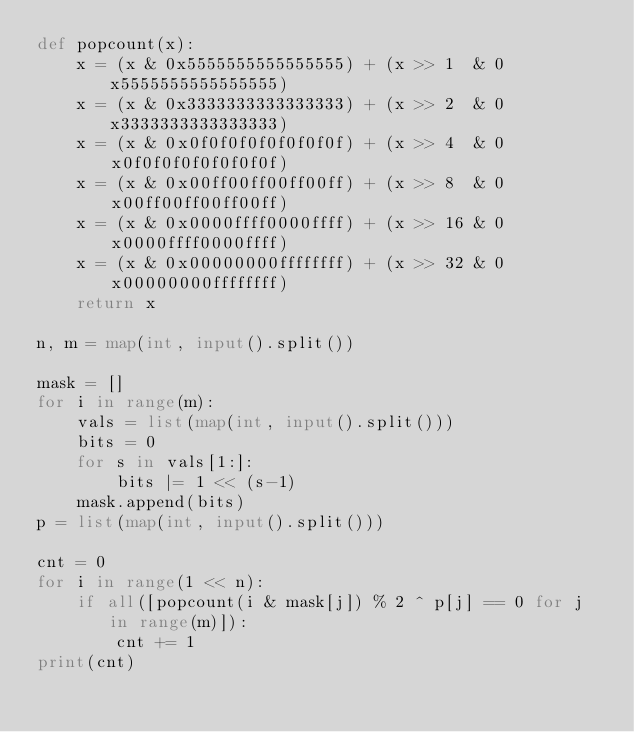Convert code to text. <code><loc_0><loc_0><loc_500><loc_500><_Python_>def popcount(x):
    x = (x & 0x5555555555555555) + (x >> 1  & 0x5555555555555555)
    x = (x & 0x3333333333333333) + (x >> 2  & 0x3333333333333333)
    x = (x & 0x0f0f0f0f0f0f0f0f) + (x >> 4  & 0x0f0f0f0f0f0f0f0f)
    x = (x & 0x00ff00ff00ff00ff) + (x >> 8  & 0x00ff00ff00ff00ff)
    x = (x & 0x0000ffff0000ffff) + (x >> 16 & 0x0000ffff0000ffff)
    x = (x & 0x00000000ffffffff) + (x >> 32 & 0x00000000ffffffff)
    return x

n, m = map(int, input().split())

mask = []
for i in range(m):
    vals = list(map(int, input().split()))
    bits = 0
    for s in vals[1:]:
        bits |= 1 << (s-1)
    mask.append(bits)
p = list(map(int, input().split()))

cnt = 0
for i in range(1 << n):
    if all([popcount(i & mask[j]) % 2 ^ p[j] == 0 for j in range(m)]):
        cnt += 1
print(cnt)
    

</code> 